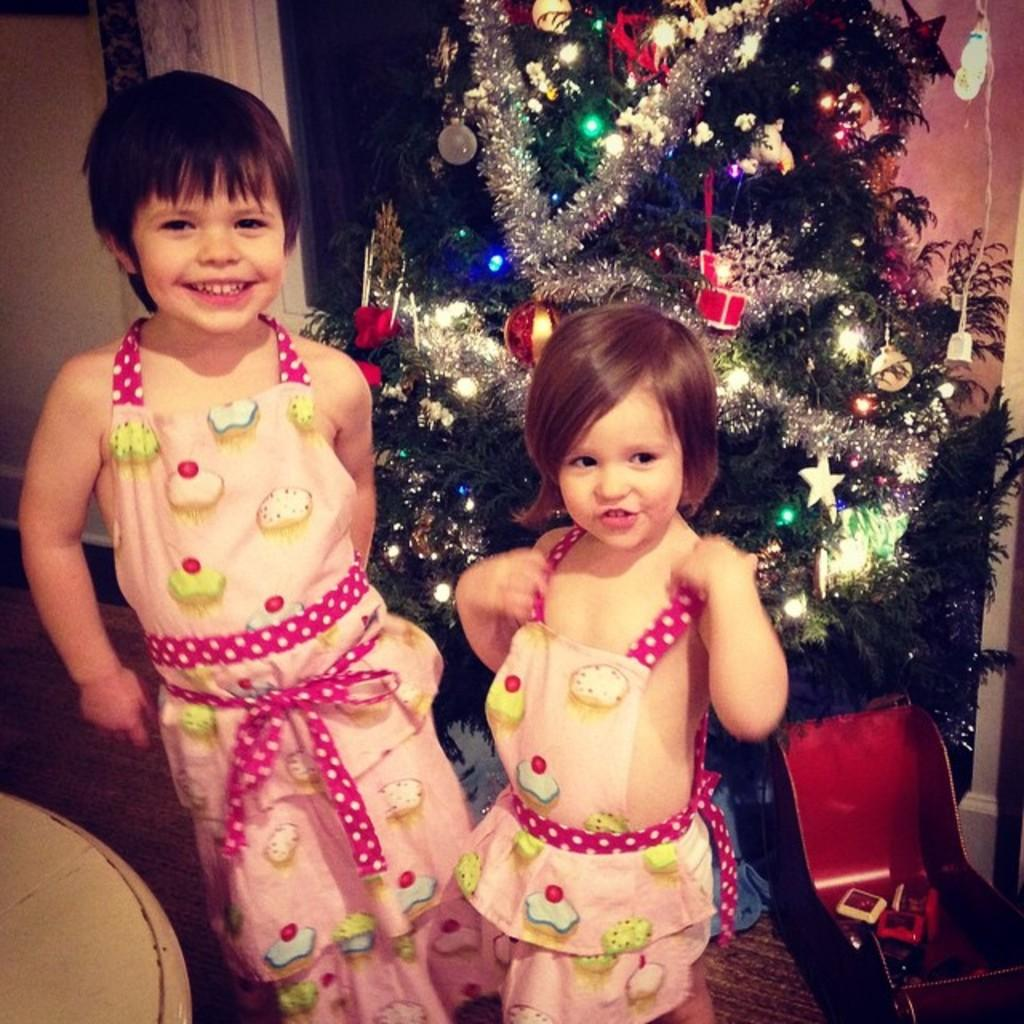How many kids are present in the image? There are two kids standing in the image. What can be seen in the background of the image? There is a Christmas tree and a wall in the background of the image. Where is the table located in the image? The table is in the bottom left of the image. What type of pipe can be seen in the image? There is no pipe present in the image. How many oranges are on the table in the image? There is no mention of oranges in the image; the table has no visible objects on it. 